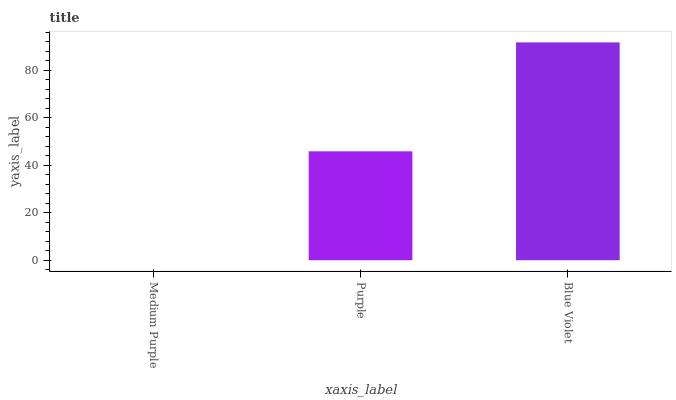Is Medium Purple the minimum?
Answer yes or no. Yes. Is Blue Violet the maximum?
Answer yes or no. Yes. Is Purple the minimum?
Answer yes or no. No. Is Purple the maximum?
Answer yes or no. No. Is Purple greater than Medium Purple?
Answer yes or no. Yes. Is Medium Purple less than Purple?
Answer yes or no. Yes. Is Medium Purple greater than Purple?
Answer yes or no. No. Is Purple less than Medium Purple?
Answer yes or no. No. Is Purple the high median?
Answer yes or no. Yes. Is Purple the low median?
Answer yes or no. Yes. Is Medium Purple the high median?
Answer yes or no. No. Is Blue Violet the low median?
Answer yes or no. No. 